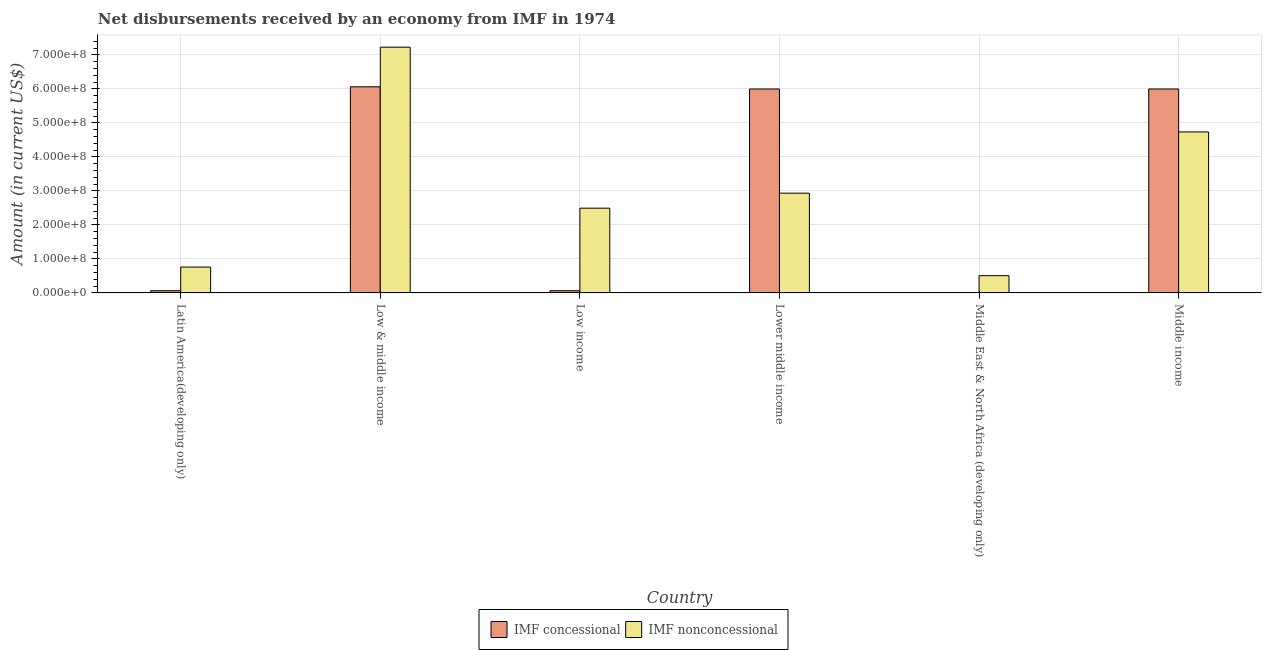How many different coloured bars are there?
Your answer should be very brief. 2. How many bars are there on the 3rd tick from the right?
Provide a succinct answer. 2. What is the label of the 6th group of bars from the left?
Give a very brief answer. Middle income. In how many cases, is the number of bars for a given country not equal to the number of legend labels?
Offer a terse response. 1. What is the net non concessional disbursements from imf in Low income?
Keep it short and to the point. 2.49e+08. Across all countries, what is the maximum net non concessional disbursements from imf?
Your response must be concise. 7.23e+08. Across all countries, what is the minimum net non concessional disbursements from imf?
Ensure brevity in your answer.  5.08e+07. What is the total net concessional disbursements from imf in the graph?
Your answer should be very brief. 1.82e+09. What is the difference between the net non concessional disbursements from imf in Latin America(developing only) and that in Lower middle income?
Keep it short and to the point. -2.17e+08. What is the difference between the net concessional disbursements from imf in Latin America(developing only) and the net non concessional disbursements from imf in Middle income?
Offer a very short reply. -4.67e+08. What is the average net non concessional disbursements from imf per country?
Provide a short and direct response. 3.11e+08. What is the difference between the net non concessional disbursements from imf and net concessional disbursements from imf in Low income?
Give a very brief answer. 2.43e+08. In how many countries, is the net non concessional disbursements from imf greater than 520000000 US$?
Your response must be concise. 1. What is the ratio of the net non concessional disbursements from imf in Latin America(developing only) to that in Middle East & North Africa (developing only)?
Make the answer very short. 1.5. Is the net concessional disbursements from imf in Low & middle income less than that in Low income?
Offer a terse response. No. Is the difference between the net concessional disbursements from imf in Low & middle income and Middle income greater than the difference between the net non concessional disbursements from imf in Low & middle income and Middle income?
Your response must be concise. No. What is the difference between the highest and the second highest net non concessional disbursements from imf?
Make the answer very short. 2.49e+08. What is the difference between the highest and the lowest net non concessional disbursements from imf?
Provide a succinct answer. 6.72e+08. In how many countries, is the net non concessional disbursements from imf greater than the average net non concessional disbursements from imf taken over all countries?
Provide a short and direct response. 2. What is the difference between two consecutive major ticks on the Y-axis?
Provide a succinct answer. 1.00e+08. Does the graph contain any zero values?
Provide a succinct answer. Yes. Does the graph contain grids?
Your answer should be very brief. Yes. How many legend labels are there?
Ensure brevity in your answer.  2. How are the legend labels stacked?
Your answer should be very brief. Horizontal. What is the title of the graph?
Your answer should be very brief. Net disbursements received by an economy from IMF in 1974. What is the label or title of the X-axis?
Provide a succinct answer. Country. What is the Amount (in current US$) of IMF concessional in Latin America(developing only)?
Give a very brief answer. 6.50e+06. What is the Amount (in current US$) of IMF nonconcessional in Latin America(developing only)?
Provide a succinct answer. 7.62e+07. What is the Amount (in current US$) in IMF concessional in Low & middle income?
Make the answer very short. 6.06e+08. What is the Amount (in current US$) in IMF nonconcessional in Low & middle income?
Offer a very short reply. 7.23e+08. What is the Amount (in current US$) of IMF concessional in Low income?
Your response must be concise. 6.50e+06. What is the Amount (in current US$) in IMF nonconcessional in Low income?
Give a very brief answer. 2.49e+08. What is the Amount (in current US$) of IMF concessional in Lower middle income?
Provide a succinct answer. 6.00e+08. What is the Amount (in current US$) in IMF nonconcessional in Lower middle income?
Your answer should be very brief. 2.93e+08. What is the Amount (in current US$) of IMF concessional in Middle East & North Africa (developing only)?
Provide a succinct answer. 0. What is the Amount (in current US$) of IMF nonconcessional in Middle East & North Africa (developing only)?
Keep it short and to the point. 5.08e+07. What is the Amount (in current US$) in IMF concessional in Middle income?
Your response must be concise. 6.00e+08. What is the Amount (in current US$) in IMF nonconcessional in Middle income?
Your answer should be compact. 4.73e+08. Across all countries, what is the maximum Amount (in current US$) of IMF concessional?
Provide a short and direct response. 6.06e+08. Across all countries, what is the maximum Amount (in current US$) in IMF nonconcessional?
Ensure brevity in your answer.  7.23e+08. Across all countries, what is the minimum Amount (in current US$) in IMF concessional?
Offer a terse response. 0. Across all countries, what is the minimum Amount (in current US$) of IMF nonconcessional?
Your response must be concise. 5.08e+07. What is the total Amount (in current US$) of IMF concessional in the graph?
Offer a terse response. 1.82e+09. What is the total Amount (in current US$) in IMF nonconcessional in the graph?
Offer a very short reply. 1.87e+09. What is the difference between the Amount (in current US$) of IMF concessional in Latin America(developing only) and that in Low & middle income?
Your response must be concise. -6.00e+08. What is the difference between the Amount (in current US$) in IMF nonconcessional in Latin America(developing only) and that in Low & middle income?
Your answer should be very brief. -6.47e+08. What is the difference between the Amount (in current US$) in IMF nonconcessional in Latin America(developing only) and that in Low income?
Keep it short and to the point. -1.73e+08. What is the difference between the Amount (in current US$) in IMF concessional in Latin America(developing only) and that in Lower middle income?
Your response must be concise. -5.93e+08. What is the difference between the Amount (in current US$) in IMF nonconcessional in Latin America(developing only) and that in Lower middle income?
Your answer should be very brief. -2.17e+08. What is the difference between the Amount (in current US$) in IMF nonconcessional in Latin America(developing only) and that in Middle East & North Africa (developing only)?
Your answer should be compact. 2.53e+07. What is the difference between the Amount (in current US$) in IMF concessional in Latin America(developing only) and that in Middle income?
Your answer should be very brief. -5.93e+08. What is the difference between the Amount (in current US$) of IMF nonconcessional in Latin America(developing only) and that in Middle income?
Make the answer very short. -3.97e+08. What is the difference between the Amount (in current US$) of IMF concessional in Low & middle income and that in Low income?
Your answer should be compact. 6.00e+08. What is the difference between the Amount (in current US$) of IMF nonconcessional in Low & middle income and that in Low income?
Provide a succinct answer. 4.73e+08. What is the difference between the Amount (in current US$) in IMF concessional in Low & middle income and that in Lower middle income?
Your answer should be very brief. 6.50e+06. What is the difference between the Amount (in current US$) in IMF nonconcessional in Low & middle income and that in Lower middle income?
Your answer should be compact. 4.29e+08. What is the difference between the Amount (in current US$) in IMF nonconcessional in Low & middle income and that in Middle East & North Africa (developing only)?
Your answer should be compact. 6.72e+08. What is the difference between the Amount (in current US$) of IMF concessional in Low & middle income and that in Middle income?
Keep it short and to the point. 6.50e+06. What is the difference between the Amount (in current US$) of IMF nonconcessional in Low & middle income and that in Middle income?
Keep it short and to the point. 2.49e+08. What is the difference between the Amount (in current US$) of IMF concessional in Low income and that in Lower middle income?
Your answer should be very brief. -5.93e+08. What is the difference between the Amount (in current US$) of IMF nonconcessional in Low income and that in Lower middle income?
Ensure brevity in your answer.  -4.41e+07. What is the difference between the Amount (in current US$) of IMF nonconcessional in Low income and that in Middle East & North Africa (developing only)?
Your response must be concise. 1.99e+08. What is the difference between the Amount (in current US$) in IMF concessional in Low income and that in Middle income?
Your response must be concise. -5.93e+08. What is the difference between the Amount (in current US$) of IMF nonconcessional in Low income and that in Middle income?
Your answer should be compact. -2.24e+08. What is the difference between the Amount (in current US$) of IMF nonconcessional in Lower middle income and that in Middle East & North Africa (developing only)?
Make the answer very short. 2.43e+08. What is the difference between the Amount (in current US$) of IMF nonconcessional in Lower middle income and that in Middle income?
Offer a terse response. -1.80e+08. What is the difference between the Amount (in current US$) in IMF nonconcessional in Middle East & North Africa (developing only) and that in Middle income?
Your answer should be compact. -4.23e+08. What is the difference between the Amount (in current US$) of IMF concessional in Latin America(developing only) and the Amount (in current US$) of IMF nonconcessional in Low & middle income?
Ensure brevity in your answer.  -7.16e+08. What is the difference between the Amount (in current US$) of IMF concessional in Latin America(developing only) and the Amount (in current US$) of IMF nonconcessional in Low income?
Ensure brevity in your answer.  -2.43e+08. What is the difference between the Amount (in current US$) in IMF concessional in Latin America(developing only) and the Amount (in current US$) in IMF nonconcessional in Lower middle income?
Make the answer very short. -2.87e+08. What is the difference between the Amount (in current US$) in IMF concessional in Latin America(developing only) and the Amount (in current US$) in IMF nonconcessional in Middle East & North Africa (developing only)?
Make the answer very short. -4.43e+07. What is the difference between the Amount (in current US$) of IMF concessional in Latin America(developing only) and the Amount (in current US$) of IMF nonconcessional in Middle income?
Give a very brief answer. -4.67e+08. What is the difference between the Amount (in current US$) in IMF concessional in Low & middle income and the Amount (in current US$) in IMF nonconcessional in Low income?
Make the answer very short. 3.57e+08. What is the difference between the Amount (in current US$) in IMF concessional in Low & middle income and the Amount (in current US$) in IMF nonconcessional in Lower middle income?
Provide a succinct answer. 3.13e+08. What is the difference between the Amount (in current US$) in IMF concessional in Low & middle income and the Amount (in current US$) in IMF nonconcessional in Middle East & North Africa (developing only)?
Provide a short and direct response. 5.55e+08. What is the difference between the Amount (in current US$) of IMF concessional in Low & middle income and the Amount (in current US$) of IMF nonconcessional in Middle income?
Provide a short and direct response. 1.33e+08. What is the difference between the Amount (in current US$) in IMF concessional in Low income and the Amount (in current US$) in IMF nonconcessional in Lower middle income?
Provide a short and direct response. -2.87e+08. What is the difference between the Amount (in current US$) in IMF concessional in Low income and the Amount (in current US$) in IMF nonconcessional in Middle East & North Africa (developing only)?
Your answer should be compact. -4.43e+07. What is the difference between the Amount (in current US$) of IMF concessional in Low income and the Amount (in current US$) of IMF nonconcessional in Middle income?
Give a very brief answer. -4.67e+08. What is the difference between the Amount (in current US$) of IMF concessional in Lower middle income and the Amount (in current US$) of IMF nonconcessional in Middle East & North Africa (developing only)?
Give a very brief answer. 5.49e+08. What is the difference between the Amount (in current US$) of IMF concessional in Lower middle income and the Amount (in current US$) of IMF nonconcessional in Middle income?
Your response must be concise. 1.26e+08. What is the average Amount (in current US$) in IMF concessional per country?
Your response must be concise. 3.03e+08. What is the average Amount (in current US$) in IMF nonconcessional per country?
Provide a succinct answer. 3.11e+08. What is the difference between the Amount (in current US$) of IMF concessional and Amount (in current US$) of IMF nonconcessional in Latin America(developing only)?
Make the answer very short. -6.97e+07. What is the difference between the Amount (in current US$) of IMF concessional and Amount (in current US$) of IMF nonconcessional in Low & middle income?
Ensure brevity in your answer.  -1.17e+08. What is the difference between the Amount (in current US$) of IMF concessional and Amount (in current US$) of IMF nonconcessional in Low income?
Keep it short and to the point. -2.43e+08. What is the difference between the Amount (in current US$) in IMF concessional and Amount (in current US$) in IMF nonconcessional in Lower middle income?
Offer a terse response. 3.06e+08. What is the difference between the Amount (in current US$) in IMF concessional and Amount (in current US$) in IMF nonconcessional in Middle income?
Give a very brief answer. 1.26e+08. What is the ratio of the Amount (in current US$) in IMF concessional in Latin America(developing only) to that in Low & middle income?
Ensure brevity in your answer.  0.01. What is the ratio of the Amount (in current US$) in IMF nonconcessional in Latin America(developing only) to that in Low & middle income?
Offer a very short reply. 0.11. What is the ratio of the Amount (in current US$) in IMF nonconcessional in Latin America(developing only) to that in Low income?
Offer a very short reply. 0.31. What is the ratio of the Amount (in current US$) of IMF concessional in Latin America(developing only) to that in Lower middle income?
Your answer should be compact. 0.01. What is the ratio of the Amount (in current US$) in IMF nonconcessional in Latin America(developing only) to that in Lower middle income?
Offer a very short reply. 0.26. What is the ratio of the Amount (in current US$) in IMF nonconcessional in Latin America(developing only) to that in Middle East & North Africa (developing only)?
Offer a terse response. 1.5. What is the ratio of the Amount (in current US$) in IMF concessional in Latin America(developing only) to that in Middle income?
Make the answer very short. 0.01. What is the ratio of the Amount (in current US$) in IMF nonconcessional in Latin America(developing only) to that in Middle income?
Offer a terse response. 0.16. What is the ratio of the Amount (in current US$) of IMF concessional in Low & middle income to that in Low income?
Your response must be concise. 93.27. What is the ratio of the Amount (in current US$) of IMF nonconcessional in Low & middle income to that in Low income?
Your response must be concise. 2.9. What is the ratio of the Amount (in current US$) of IMF concessional in Low & middle income to that in Lower middle income?
Keep it short and to the point. 1.01. What is the ratio of the Amount (in current US$) of IMF nonconcessional in Low & middle income to that in Lower middle income?
Your answer should be compact. 2.46. What is the ratio of the Amount (in current US$) in IMF nonconcessional in Low & middle income to that in Middle East & North Africa (developing only)?
Your answer should be very brief. 14.22. What is the ratio of the Amount (in current US$) of IMF concessional in Low & middle income to that in Middle income?
Provide a short and direct response. 1.01. What is the ratio of the Amount (in current US$) in IMF nonconcessional in Low & middle income to that in Middle income?
Offer a very short reply. 1.53. What is the ratio of the Amount (in current US$) in IMF concessional in Low income to that in Lower middle income?
Offer a very short reply. 0.01. What is the ratio of the Amount (in current US$) of IMF nonconcessional in Low income to that in Lower middle income?
Offer a terse response. 0.85. What is the ratio of the Amount (in current US$) of IMF nonconcessional in Low income to that in Middle East & North Africa (developing only)?
Make the answer very short. 4.91. What is the ratio of the Amount (in current US$) of IMF concessional in Low income to that in Middle income?
Provide a succinct answer. 0.01. What is the ratio of the Amount (in current US$) in IMF nonconcessional in Low income to that in Middle income?
Offer a very short reply. 0.53. What is the ratio of the Amount (in current US$) in IMF nonconcessional in Lower middle income to that in Middle East & North Africa (developing only)?
Provide a succinct answer. 5.77. What is the ratio of the Amount (in current US$) of IMF concessional in Lower middle income to that in Middle income?
Offer a very short reply. 1. What is the ratio of the Amount (in current US$) in IMF nonconcessional in Lower middle income to that in Middle income?
Your response must be concise. 0.62. What is the ratio of the Amount (in current US$) in IMF nonconcessional in Middle East & North Africa (developing only) to that in Middle income?
Provide a short and direct response. 0.11. What is the difference between the highest and the second highest Amount (in current US$) of IMF concessional?
Provide a succinct answer. 6.50e+06. What is the difference between the highest and the second highest Amount (in current US$) in IMF nonconcessional?
Your answer should be very brief. 2.49e+08. What is the difference between the highest and the lowest Amount (in current US$) of IMF concessional?
Ensure brevity in your answer.  6.06e+08. What is the difference between the highest and the lowest Amount (in current US$) in IMF nonconcessional?
Offer a very short reply. 6.72e+08. 